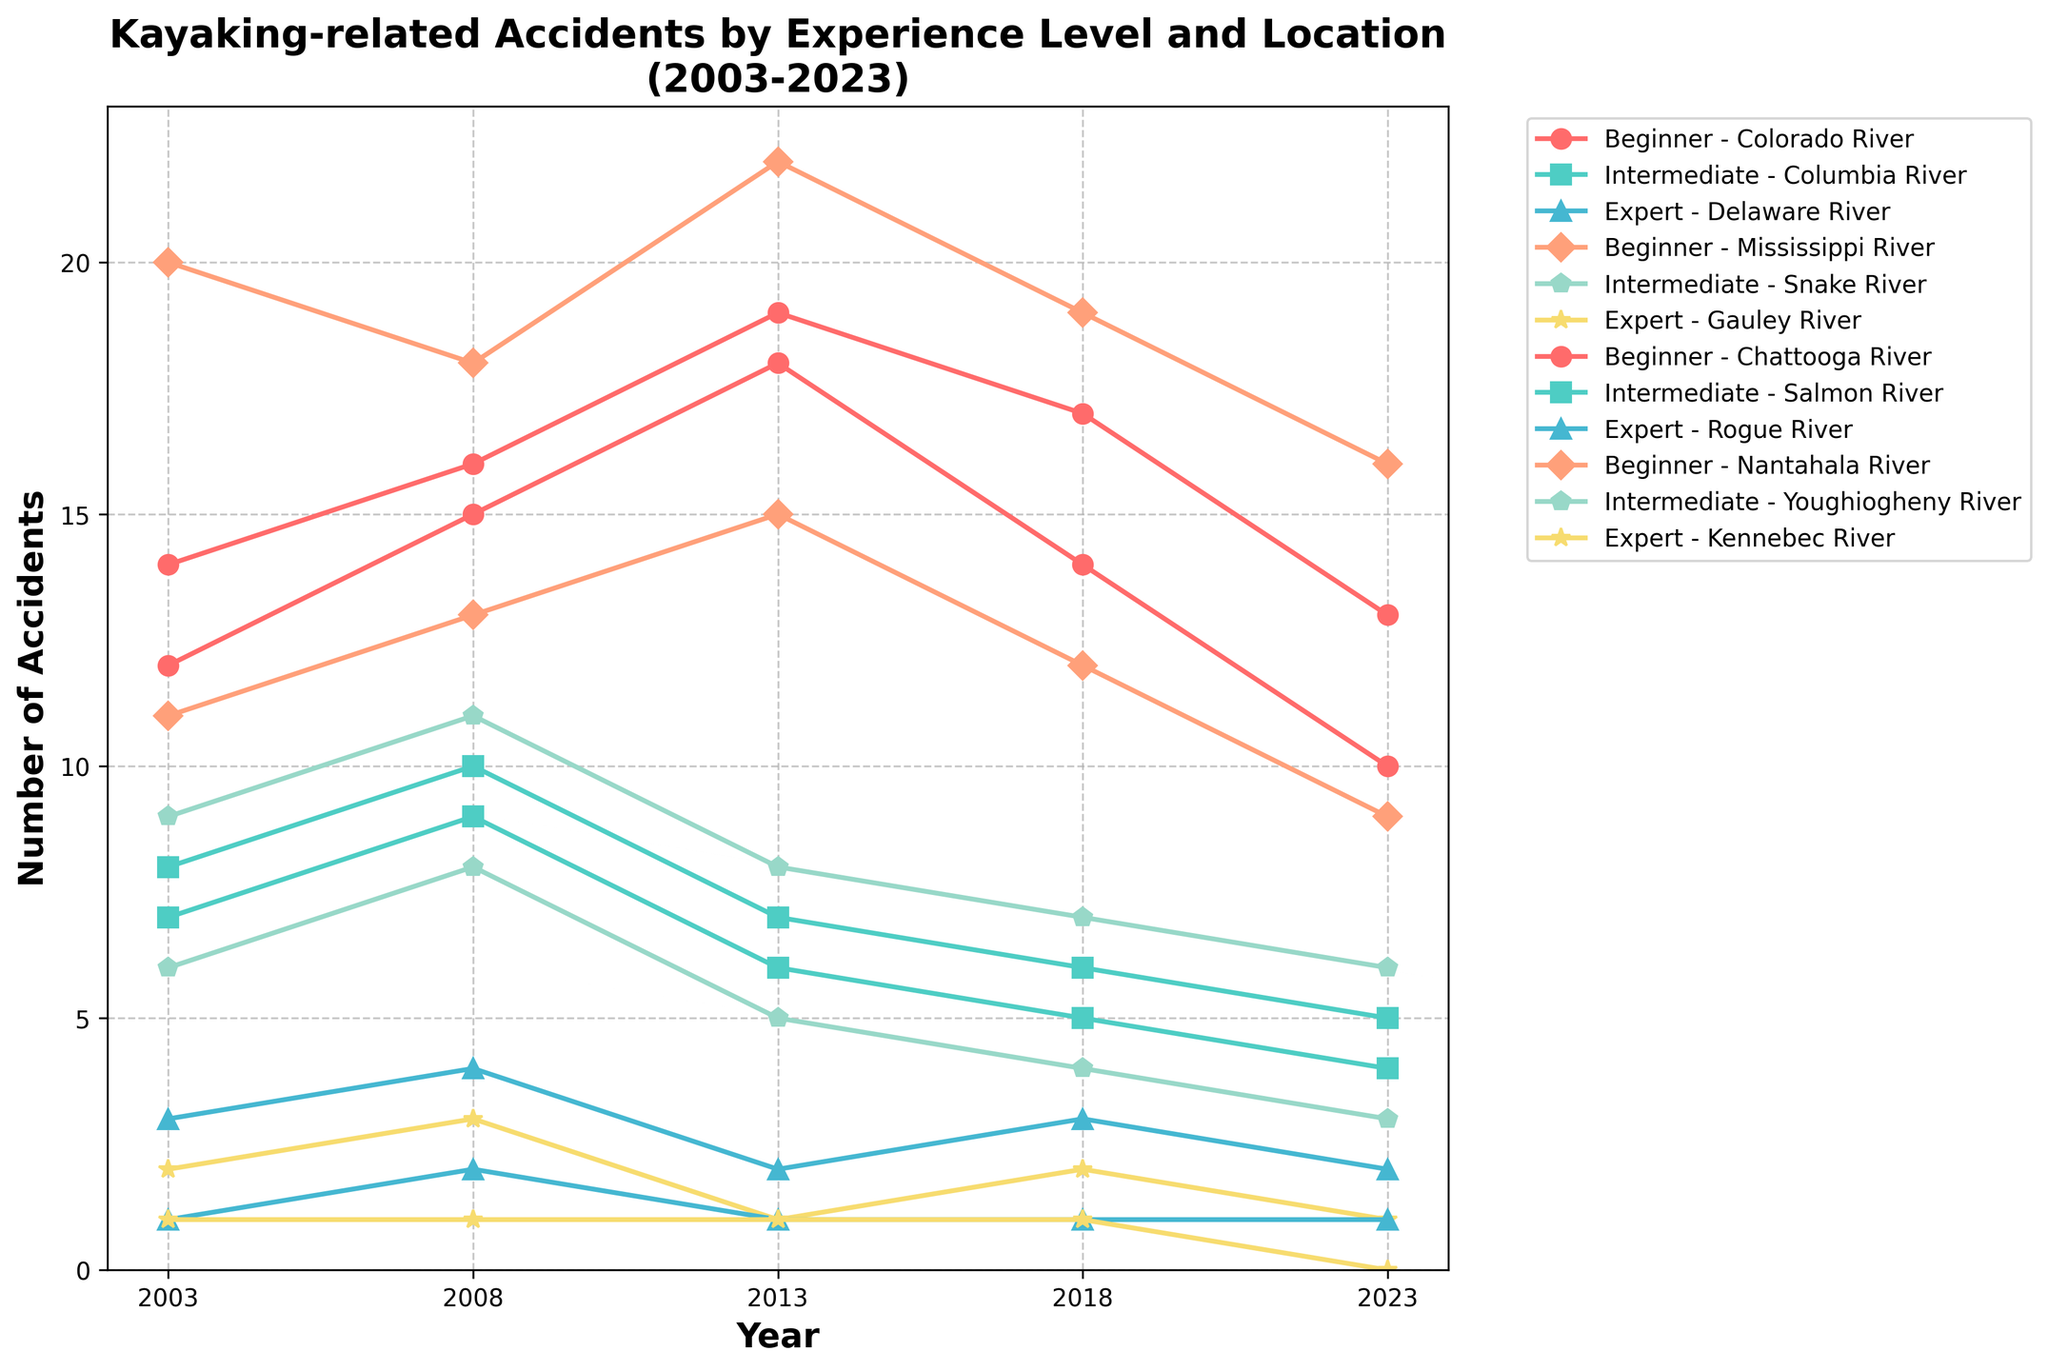What is the total number of accidents for beginners on the Mississippi River over the 20 years? To find the total number of accidents for beginners on the Mississippi River, sum the values for the years 2003, 2008, 2013, 2018, and 2023: 20 + 18 + 22 + 19 + 16 = 95.
Answer: 95 Which river experienced the highest number of accidents for beginners in 2023? Identify the number of accidents for beginners in 2023 across all rivers and find the maximum value. The values are Colorado River: 10, Mississippi River: 16, Chattooga River: 13, Nantahala River: 9. The highest value is 16 on the Mississippi River.
Answer: Mississippi River What is the average number of accidents for experts on the Gauley River? To calculate the average, sum the values over the years 2003, 2008, 2013, 2018, and 2023 and divide by 5: (2 + 3 + 1 + 2 + 1) / 5 = 9 / 5 = 1.8.
Answer: 1.8 How does the trend of accidents for intermediates on the Columbia River compare to that on the Snake River? Observe and compare the trends for intermediate level accidents on the Columbia River and Snake River over the years. Columbia River shows a decreasing trend from 8 to 5, and Snake River also shows a decreasing trend from 9 to 6. Both rivers show a similar decreasing trend.
Answer: Both decreasing Which location had the most accidents for experts in 2013? Identify the number of accidents for experts in 2013 across all rivers and find the maximum value. The values are Delaware River: 2, Gauley River: 1, Rogue River: 1, Kennebec River: 1. The highest value is 2 on the Delaware River.
Answer: Delaware River What is the difference in the number of beginner accidents between the Chattooga River and the Nantahala River in 2013? To find the difference, subtract the number of beginner accidents in the Nantahala River from the Chattooga River in 2013: 19 - 15 = 4.
Answer: 4 Which experience level on the Nantahala River experienced the highest decrease in accidents from 2003 to 2023? Calculate the decrease in accidents for each experience level on the Nantahala River from 2003 to 2023, and identify the largest drop. Beginners: 11 - 9 = 2 decrease; Intermediates: not applicable; Experts: not applicable. Beginners had the highest and only decrease of 2.
Answer: Beginners Does the Colorado River show an overall increasing or decreasing trend in accidents for beginners from 2003 to 2023? Observe the trend of accidents for beginners on the Colorado River from 2003 to 2023 across all years. The values are: 12, 15, 18, 14, 10. The numbers first increase and then decrease, showing no clear overall increasing or decreasing trend. However, from a strictly initial to final year perspective, it decreases from 12 to 10.
Answer: Decreasing How does the number of accidents for intermediates on the Salmon River in 2008 compare to those on the Youghiogheny River in 2018? Compare the number of intermediate accidents on the Salmon River in 2008 (9) to those on the Youghiogheny River in 2018 (4). The Salmon River had more accidents (9 versus 4).
Answer: Salmon River had more 